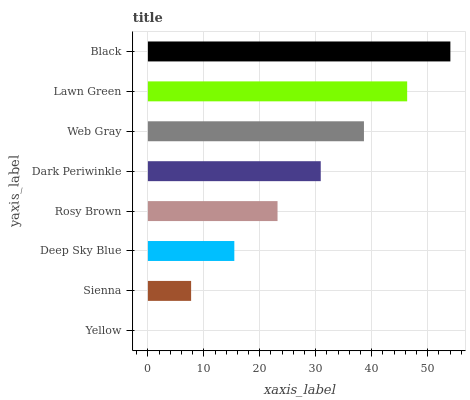Is Yellow the minimum?
Answer yes or no. Yes. Is Black the maximum?
Answer yes or no. Yes. Is Sienna the minimum?
Answer yes or no. No. Is Sienna the maximum?
Answer yes or no. No. Is Sienna greater than Yellow?
Answer yes or no. Yes. Is Yellow less than Sienna?
Answer yes or no. Yes. Is Yellow greater than Sienna?
Answer yes or no. No. Is Sienna less than Yellow?
Answer yes or no. No. Is Dark Periwinkle the high median?
Answer yes or no. Yes. Is Rosy Brown the low median?
Answer yes or no. Yes. Is Sienna the high median?
Answer yes or no. No. Is Sienna the low median?
Answer yes or no. No. 